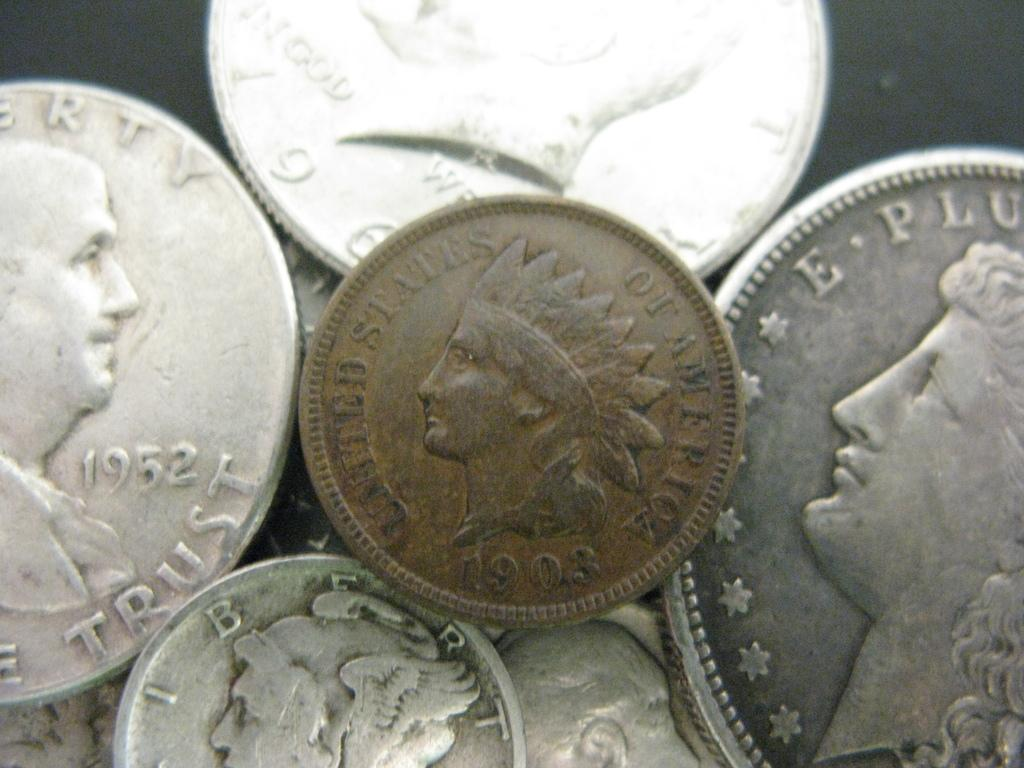<image>
Render a clear and concise summary of the photo. several old United States of America coins minted in 1902 and 1952 